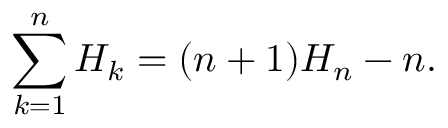Convert formula to latex. <formula><loc_0><loc_0><loc_500><loc_500>\sum _ { k = 1 } ^ { n } H _ { k } = ( n + 1 ) H _ { n } - n .</formula> 